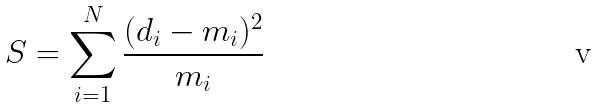Convert formula to latex. <formula><loc_0><loc_0><loc_500><loc_500>S = \sum _ { i = 1 } ^ { N } \frac { ( d _ { i } - m _ { i } ) ^ { 2 } } { m _ { i } }</formula> 